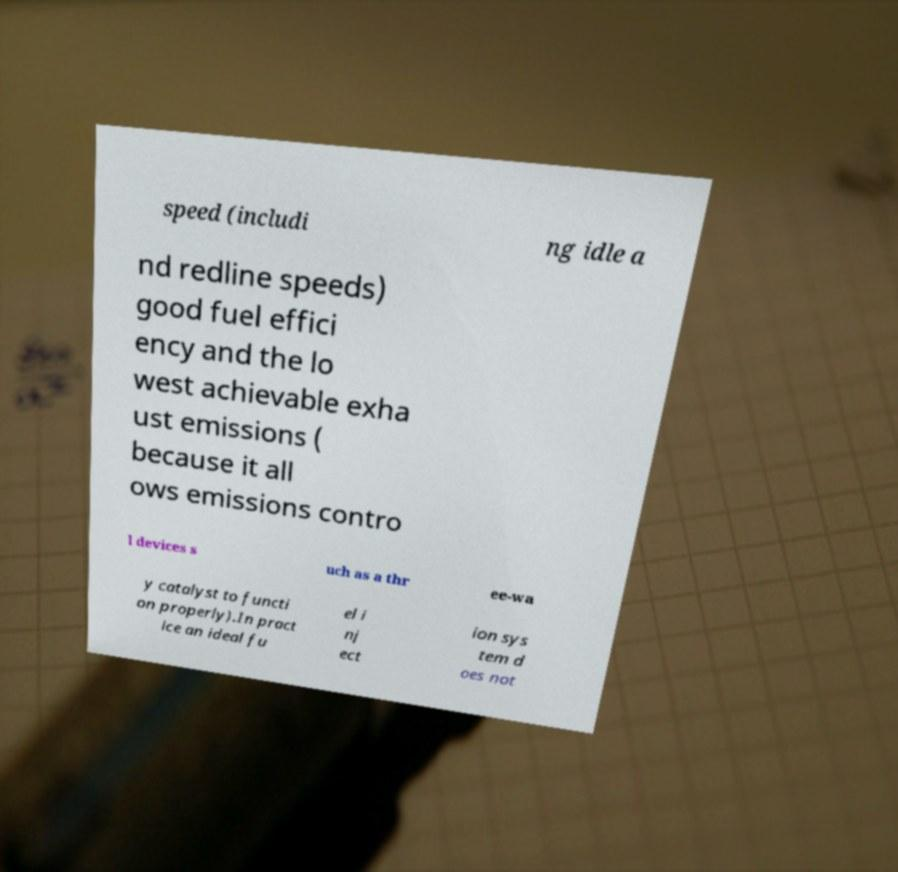There's text embedded in this image that I need extracted. Can you transcribe it verbatim? speed (includi ng idle a nd redline speeds) good fuel effici ency and the lo west achievable exha ust emissions ( because it all ows emissions contro l devices s uch as a thr ee-wa y catalyst to functi on properly).In pract ice an ideal fu el i nj ect ion sys tem d oes not 